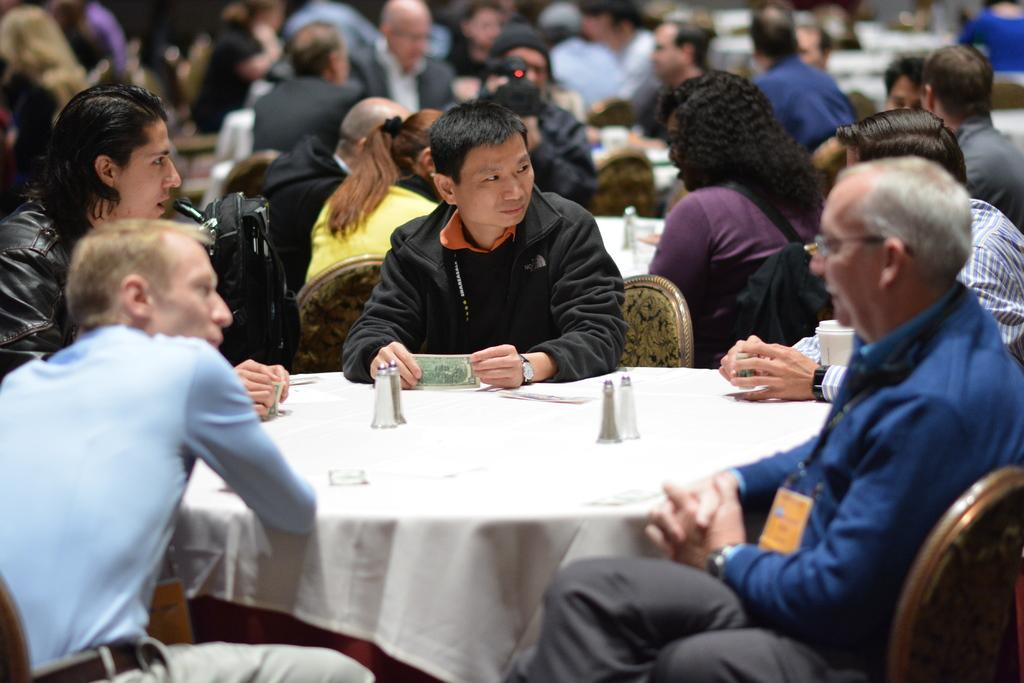How many people are sitting on chairs in the image? There are five people sitting on chairs in the image. What are the people sitting in front of? The people are sitting in front of a table. Are there any other people sitting in the image? Yes, there are other people sitting on chairs behind the first group. What are these people sitting in front of? These people are also sitting in front of tables. What type of quince is being used as a centerpiece on the table? There is no quince present in the image; it does not mention any fruit or centerpiece on the table. 